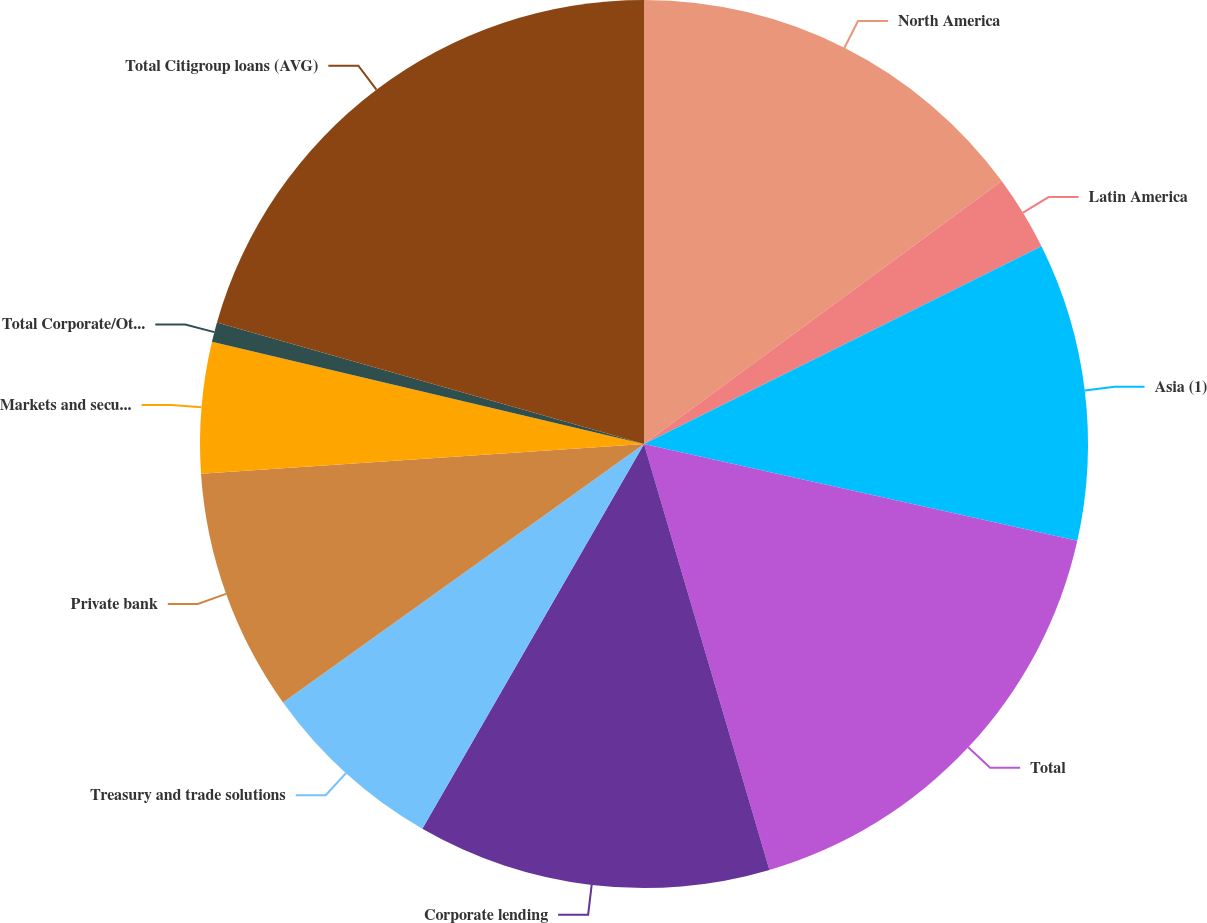<chart> <loc_0><loc_0><loc_500><loc_500><pie_chart><fcel>North America<fcel>Latin America<fcel>Asia (1)<fcel>Total<fcel>Corporate lending<fcel>Treasury and trade solutions<fcel>Private bank<fcel>Markets and securities<fcel>Total Corporate/Other<fcel>Total Citigroup loans (AVG)<nl><fcel>14.91%<fcel>2.74%<fcel>10.85%<fcel>16.94%<fcel>12.88%<fcel>6.79%<fcel>8.82%<fcel>4.77%<fcel>0.71%<fcel>20.59%<nl></chart> 